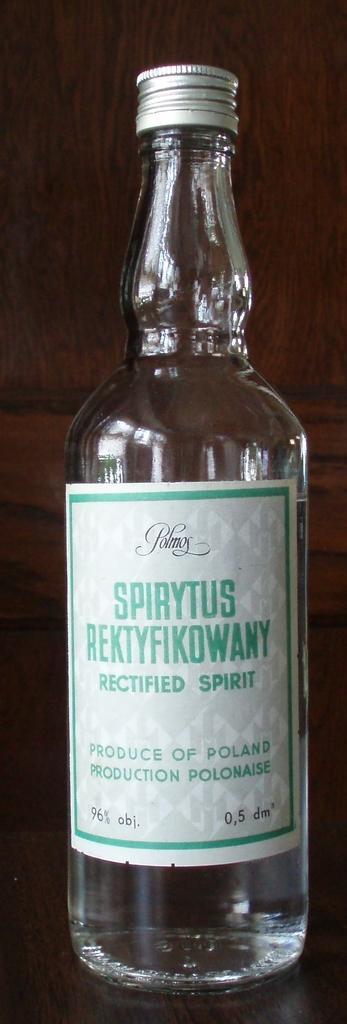Describe this image in one or two sentences. This picture is consists of a glass bottle on which it is written rectified spirit, which is placed over the table. 